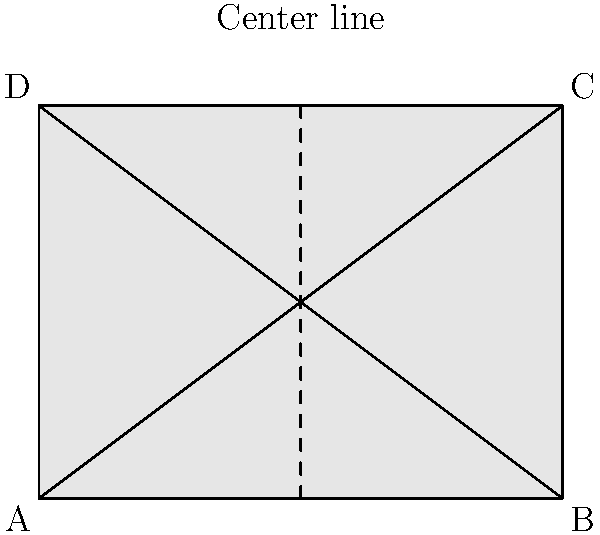The cross-section of a lightweight aircraft fuselage is shown above. If the fuselage has an elliptical cross-section with a width of 4 meters and a height of 3 meters, what is the area of this cross-section in square meters? To find the area of the elliptical cross-section, we can follow these steps:

1. Identify the semi-major (a) and semi-minor (b) axes of the ellipse:
   - Width = 4 meters, so a = 4/2 = 2 meters
   - Height = 3 meters, so b = 3/2 = 1.5 meters

2. Recall the formula for the area of an ellipse:
   $$ A = \pi ab $$

3. Substitute the values:
   $$ A = \pi \cdot 2 \cdot 1.5 $$

4. Calculate:
   $$ A = 3\pi $$

5. Approximate the result:
   $$ A \approx 3 \cdot 3.14159 \approx 9.42477 \text{ square meters} $$

Therefore, the area of the elliptical cross-section is approximately 9.42 square meters.
Answer: $3\pi$ or approximately 9.42 square meters 